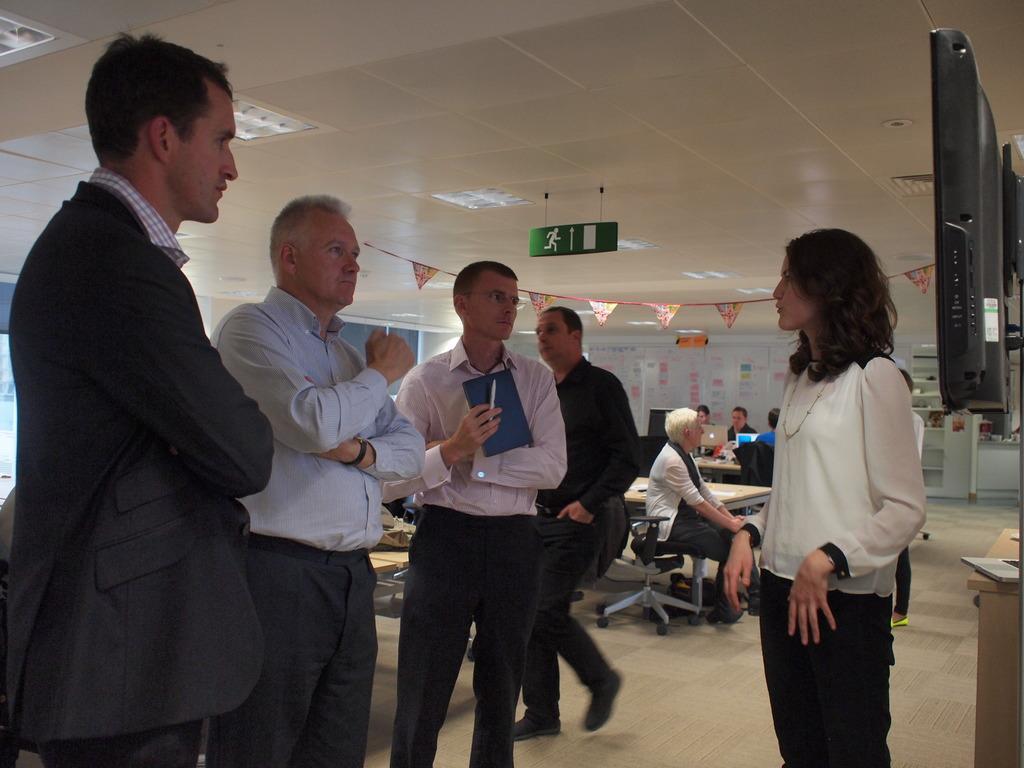Please provide a concise description of this image. Group of people are standing and discussing behind them there are lights. 